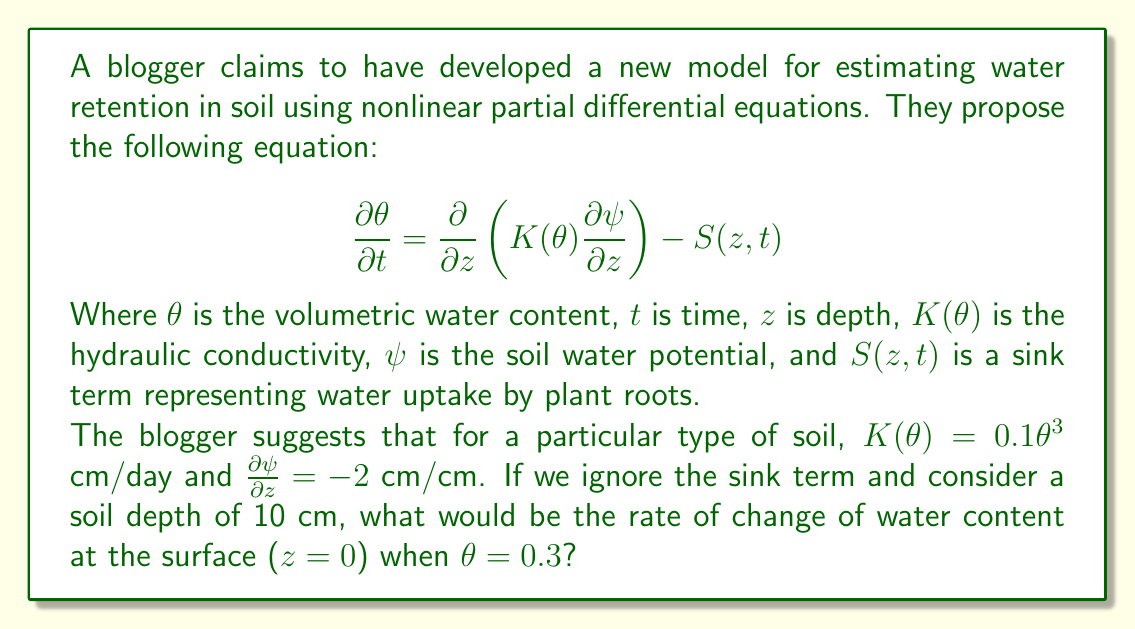Could you help me with this problem? Let's approach this step-by-step using traditional soil physics principles:

1) The given equation is a form of Richards' equation, which is indeed used in soil hydrology. However, we need to verify its applicability to our specific soil conditions.

2) We're given that $K(\theta) = 0.1\theta^3$ cm/day. This seems reasonable, as hydraulic conductivity often increases nonlinearly with water content.

3) The gradient $\frac{\partial \psi}{\partial z} = -2$ cm/cm is constant, which is a simplification but could be acceptable for a small depth range.

4) We're ignoring the sink term $S(z,t)$, which means we're not considering water uptake by plants. This might be appropriate for bare soil or short time scales.

5) Now, let's substitute these into the equation:

   $$\frac{\partial \theta}{\partial t} = \frac{\partial}{\partial z} \left(0.1\theta^3 \cdot (-2)\right)$$

6) Simplify:
   
   $$\frac{\partial \theta}{\partial t} = -0.2 \frac{\partial}{\partial z} (\theta^3)$$

7) Apply the chain rule:

   $$\frac{\partial \theta}{\partial t} = -0.2 \cdot 3\theta^2 \frac{\partial \theta}{\partial z}$$

8) At the surface ($z=0$), $\theta = 0.3$. Substitute this:

   $$\frac{\partial \theta}{\partial t} = -0.2 \cdot 3 \cdot (0.3)^2 \frac{\partial \theta}{\partial z}$$

9) Simplify:

   $$\frac{\partial \theta}{\partial t} = -0.054 \frac{\partial \theta}{\partial z}$$

10) We don't know $\frac{\partial \theta}{\partial z}$ at the surface, so we can't give a numerical answer. The rate of change of water content at the surface depends on the water content gradient at that point.
Answer: $\frac{\partial \theta}{\partial t} = -0.054 \frac{\partial \theta}{\partial z}$ cm/day 